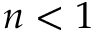Convert formula to latex. <formula><loc_0><loc_0><loc_500><loc_500>n < 1</formula> 